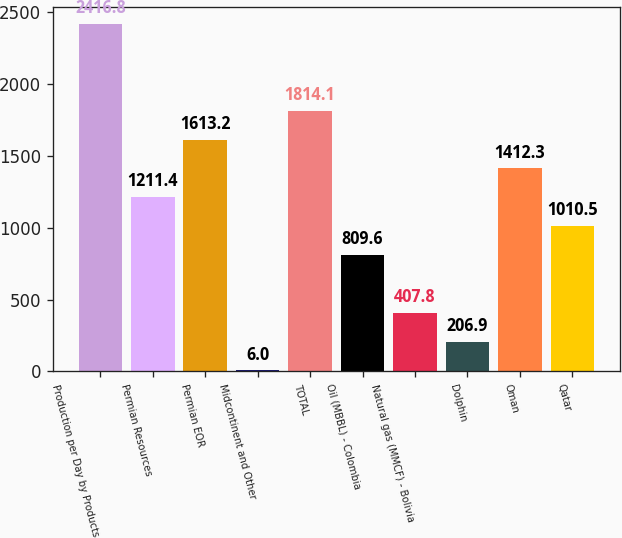Convert chart to OTSL. <chart><loc_0><loc_0><loc_500><loc_500><bar_chart><fcel>Production per Day by Products<fcel>Permian Resources<fcel>Permian EOR<fcel>Midcontinent and Other<fcel>TOTAL<fcel>Oil (MBBL) - Colombia<fcel>Natural gas (MMCF) - Bolivia<fcel>Dolphin<fcel>Oman<fcel>Qatar<nl><fcel>2416.8<fcel>1211.4<fcel>1613.2<fcel>6<fcel>1814.1<fcel>809.6<fcel>407.8<fcel>206.9<fcel>1412.3<fcel>1010.5<nl></chart> 